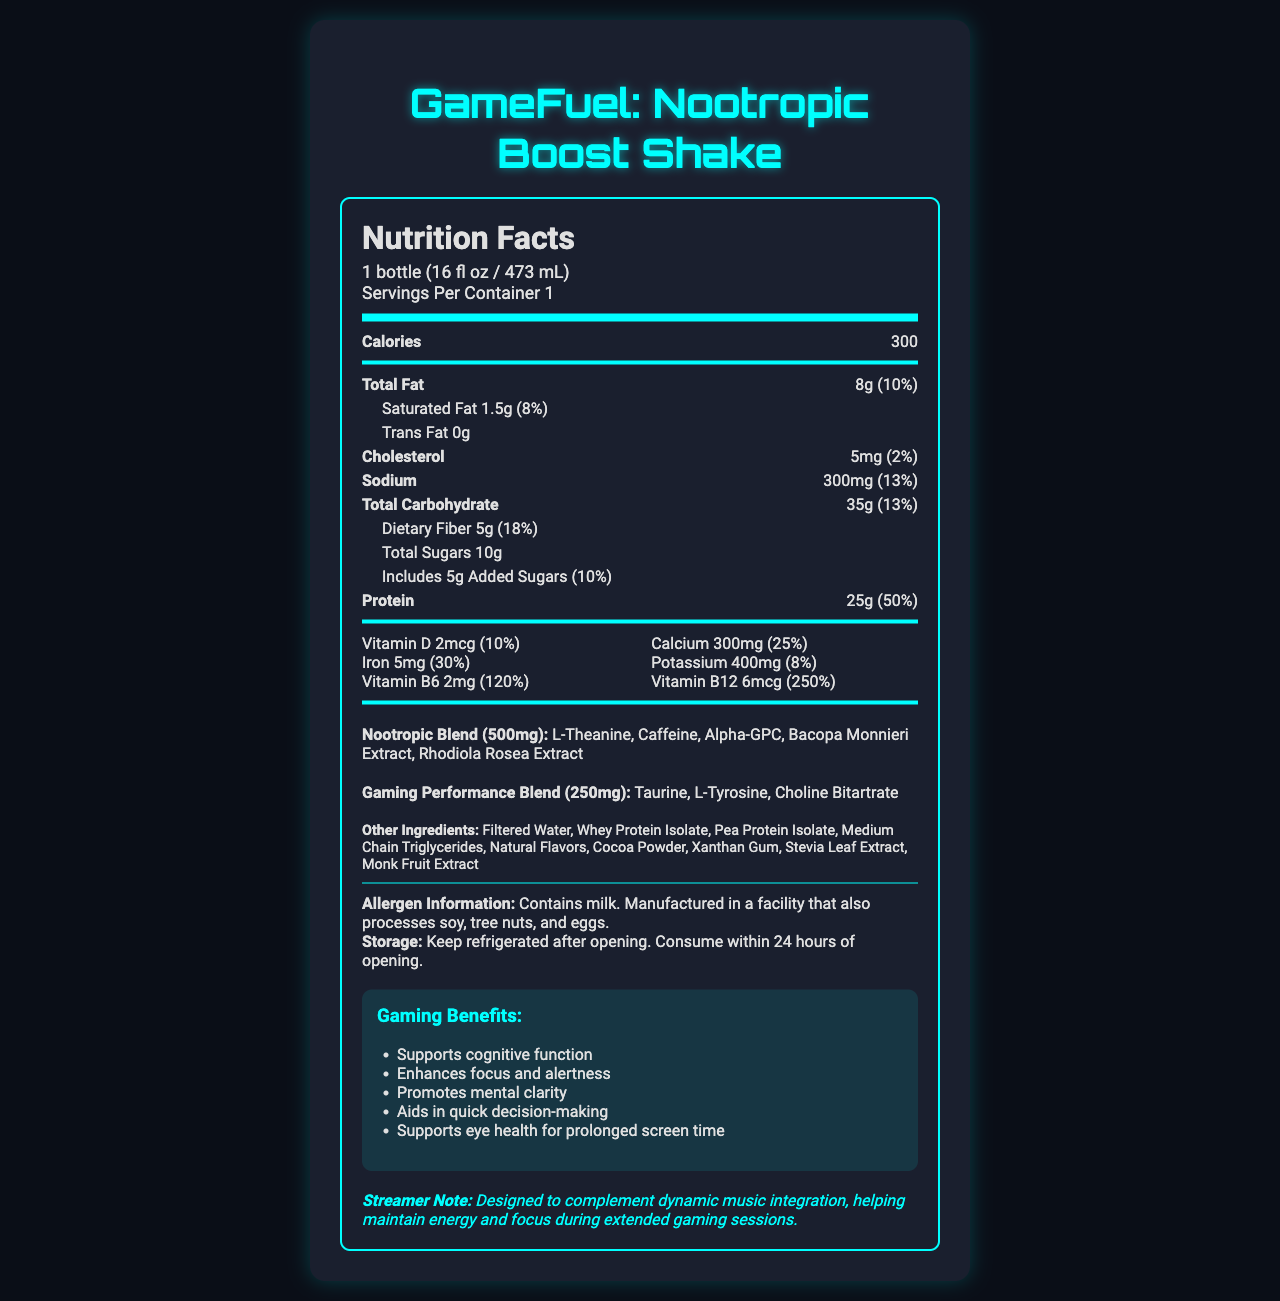What is the serving size for GameFuel: Nootropic Boost Shake? The serving size is clearly mentioned under the heading "Nutrition Facts" as 1 bottle (16 fl oz / 473 mL).
Answer: 1 bottle (16 fl oz / 473 mL) How many calories are in one serving of GameFuel: Nootropic Boost Shake? The calorie content per serving is mentioned as 300 under the "Calories" section.
Answer: 300 What percentage of the daily recommended intake of protein does one serving provide? The document specifies that one serving contains 25g of protein, which is 50% of the daily value.
Answer: 50% How much added sugar is in each serving, and what percentage of the daily value does this represent? The document lists added sugars as 5g and shows that this represents 10% of the daily value.
Answer: 5g, 10% Which vitamins and minerals are present in GameFuel: Nootropic Boost Shake? The vitamins and minerals listed under the section include Vitamin D, Calcium, Iron, Potassium, Vitamin B6, and Vitamin B12.
Answer: Vitamin D, Calcium, Iron, Potassium, Vitamin B6, Vitamin B12 Which ingredients are part of the Nootropic Blend in GameFuel: Nootropic Boost Shake? A. Taurine B. L-Theanine C. L-Tyrosine D. Choline Bitartrate The Nootropic Blend includes L-Theanine, Caffeine, Alpha-GPC, Bacopa Monnieri Extract, and Rhodiola Rosea Extract. Taurine, L-Tyrosine, and Choline Bitartrate are part of the Gaming Performance Blend.
Answer: B What is the percentage daily value of Vitamin B12 in the shake? A. 100% B. 200% C. 250% D. 300% The document states that the shake contains 6mcg of Vitamin B12, which is 250% of the daily value.
Answer: C Does GameFuel: Nootropic Boost Shake contain any trans fat? The document clearly lists trans fat as 0g.
Answer: No Does the GameFuel: Nootropic Boost Shake enhance focus and alertness? The document lists "Enhances focus and alertness" as one of the gaming benefits.
Answer: Yes Describe the main purpose of the GameFuel: Nootropic Boost Shake document. The document is formatted with headings for nutrition facts, special blends, ingredients, and additional notes, all aimed at giving a comprehensive overview of the product's health and gaming benefits.
Answer: The document provides detailed nutrition facts about GameFuel: Nootropic Boost Shake, including macronutrient content, vitamins and minerals, and special blends designed to enhance gaming performance. It also lists the ingredients, allergen information, and storage instructions. Is the exact proportion of each ingredient in the Nootropic Blend specified in the document? The document only lists the ingredients L-Theanine, Caffeine, Alpha-GPC, Bacopa Monnieri Extract, and Rhodiola Rosea Extract under the Nootropic Blend, but does not provide the exact proportions of each.
Answer: No 